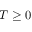<formula> <loc_0><loc_0><loc_500><loc_500>T \geq 0</formula> 